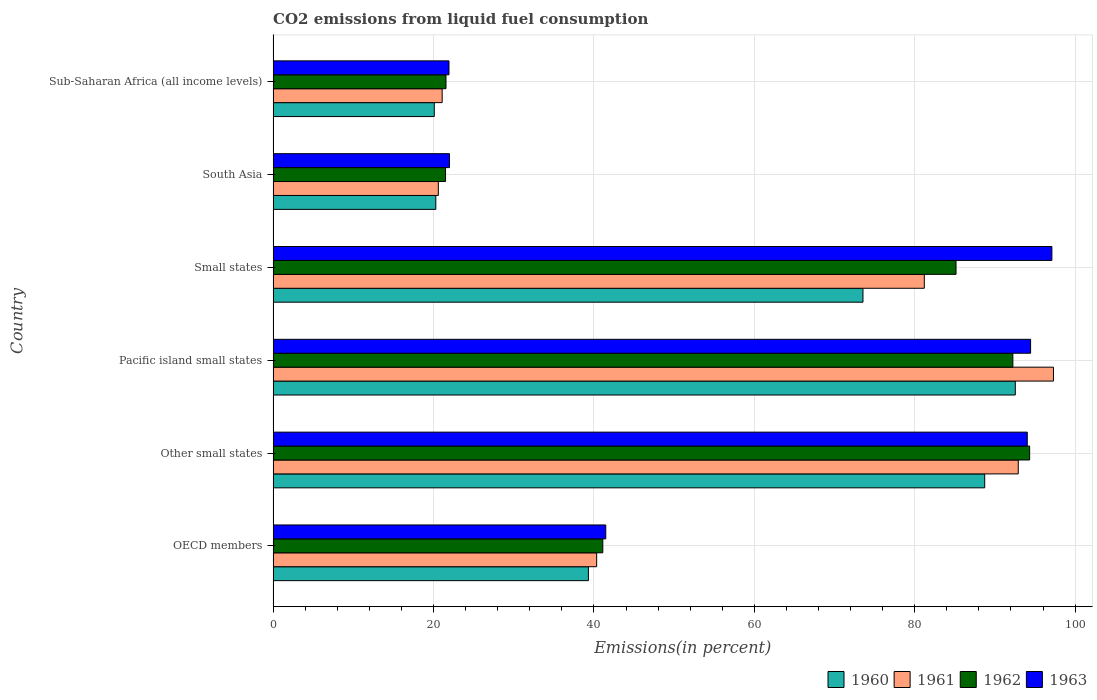How many different coloured bars are there?
Make the answer very short. 4. How many groups of bars are there?
Provide a short and direct response. 6. How many bars are there on the 2nd tick from the top?
Your answer should be very brief. 4. How many bars are there on the 1st tick from the bottom?
Your response must be concise. 4. What is the label of the 1st group of bars from the top?
Keep it short and to the point. Sub-Saharan Africa (all income levels). What is the total CO2 emitted in 1962 in Pacific island small states?
Offer a terse response. 92.23. Across all countries, what is the maximum total CO2 emitted in 1963?
Provide a succinct answer. 97.1. Across all countries, what is the minimum total CO2 emitted in 1963?
Ensure brevity in your answer.  21.93. In which country was the total CO2 emitted in 1962 maximum?
Give a very brief answer. Other small states. In which country was the total CO2 emitted in 1963 minimum?
Your response must be concise. Sub-Saharan Africa (all income levels). What is the total total CO2 emitted in 1962 in the graph?
Give a very brief answer. 355.86. What is the difference between the total CO2 emitted in 1963 in OECD members and that in South Asia?
Your answer should be compact. 19.49. What is the difference between the total CO2 emitted in 1962 in Pacific island small states and the total CO2 emitted in 1963 in Other small states?
Make the answer very short. -1.8. What is the average total CO2 emitted in 1961 per country?
Ensure brevity in your answer.  58.9. What is the difference between the total CO2 emitted in 1963 and total CO2 emitted in 1960 in Sub-Saharan Africa (all income levels)?
Make the answer very short. 1.83. What is the ratio of the total CO2 emitted in 1961 in Other small states to that in South Asia?
Make the answer very short. 4.51. What is the difference between the highest and the second highest total CO2 emitted in 1961?
Provide a short and direct response. 4.39. What is the difference between the highest and the lowest total CO2 emitted in 1961?
Make the answer very short. 76.7. Is the sum of the total CO2 emitted in 1963 in Other small states and South Asia greater than the maximum total CO2 emitted in 1960 across all countries?
Ensure brevity in your answer.  Yes. What does the 4th bar from the bottom in South Asia represents?
Offer a terse response. 1963. Is it the case that in every country, the sum of the total CO2 emitted in 1961 and total CO2 emitted in 1963 is greater than the total CO2 emitted in 1960?
Your response must be concise. Yes. How many bars are there?
Make the answer very short. 24. Are all the bars in the graph horizontal?
Make the answer very short. Yes. What is the difference between two consecutive major ticks on the X-axis?
Offer a very short reply. 20. Are the values on the major ticks of X-axis written in scientific E-notation?
Your answer should be very brief. No. Does the graph contain any zero values?
Make the answer very short. No. What is the title of the graph?
Your response must be concise. CO2 emissions from liquid fuel consumption. Does "1989" appear as one of the legend labels in the graph?
Make the answer very short. No. What is the label or title of the X-axis?
Your answer should be very brief. Emissions(in percent). What is the Emissions(in percent) in 1960 in OECD members?
Make the answer very short. 39.31. What is the Emissions(in percent) of 1961 in OECD members?
Ensure brevity in your answer.  40.34. What is the Emissions(in percent) of 1962 in OECD members?
Provide a short and direct response. 41.1. What is the Emissions(in percent) in 1963 in OECD members?
Your answer should be compact. 41.48. What is the Emissions(in percent) in 1960 in Other small states?
Offer a very short reply. 88.72. What is the Emissions(in percent) in 1961 in Other small states?
Your answer should be compact. 92.91. What is the Emissions(in percent) in 1962 in Other small states?
Ensure brevity in your answer.  94.33. What is the Emissions(in percent) in 1963 in Other small states?
Offer a very short reply. 94.03. What is the Emissions(in percent) of 1960 in Pacific island small states?
Your answer should be compact. 92.54. What is the Emissions(in percent) of 1961 in Pacific island small states?
Ensure brevity in your answer.  97.3. What is the Emissions(in percent) in 1962 in Pacific island small states?
Give a very brief answer. 92.23. What is the Emissions(in percent) of 1963 in Pacific island small states?
Your answer should be compact. 94.44. What is the Emissions(in percent) of 1960 in Small states?
Keep it short and to the point. 73.54. What is the Emissions(in percent) of 1961 in Small states?
Provide a short and direct response. 81.19. What is the Emissions(in percent) of 1962 in Small states?
Your answer should be compact. 85.15. What is the Emissions(in percent) in 1963 in Small states?
Your answer should be very brief. 97.1. What is the Emissions(in percent) in 1960 in South Asia?
Give a very brief answer. 20.29. What is the Emissions(in percent) in 1961 in South Asia?
Give a very brief answer. 20.6. What is the Emissions(in percent) in 1962 in South Asia?
Offer a very short reply. 21.5. What is the Emissions(in percent) in 1963 in South Asia?
Your answer should be very brief. 21.99. What is the Emissions(in percent) in 1960 in Sub-Saharan Africa (all income levels)?
Your answer should be very brief. 20.09. What is the Emissions(in percent) of 1961 in Sub-Saharan Africa (all income levels)?
Your answer should be compact. 21.08. What is the Emissions(in percent) of 1962 in Sub-Saharan Africa (all income levels)?
Offer a terse response. 21.55. What is the Emissions(in percent) in 1963 in Sub-Saharan Africa (all income levels)?
Make the answer very short. 21.93. Across all countries, what is the maximum Emissions(in percent) of 1960?
Your response must be concise. 92.54. Across all countries, what is the maximum Emissions(in percent) of 1961?
Give a very brief answer. 97.3. Across all countries, what is the maximum Emissions(in percent) of 1962?
Give a very brief answer. 94.33. Across all countries, what is the maximum Emissions(in percent) in 1963?
Give a very brief answer. 97.1. Across all countries, what is the minimum Emissions(in percent) of 1960?
Give a very brief answer. 20.09. Across all countries, what is the minimum Emissions(in percent) of 1961?
Your answer should be compact. 20.6. Across all countries, what is the minimum Emissions(in percent) of 1962?
Provide a succinct answer. 21.5. Across all countries, what is the minimum Emissions(in percent) of 1963?
Give a very brief answer. 21.93. What is the total Emissions(in percent) of 1960 in the graph?
Your response must be concise. 334.5. What is the total Emissions(in percent) of 1961 in the graph?
Keep it short and to the point. 353.41. What is the total Emissions(in percent) of 1962 in the graph?
Give a very brief answer. 355.86. What is the total Emissions(in percent) in 1963 in the graph?
Offer a very short reply. 370.97. What is the difference between the Emissions(in percent) of 1960 in OECD members and that in Other small states?
Provide a short and direct response. -49.41. What is the difference between the Emissions(in percent) of 1961 in OECD members and that in Other small states?
Make the answer very short. -52.57. What is the difference between the Emissions(in percent) of 1962 in OECD members and that in Other small states?
Give a very brief answer. -53.22. What is the difference between the Emissions(in percent) of 1963 in OECD members and that in Other small states?
Your response must be concise. -52.55. What is the difference between the Emissions(in percent) of 1960 in OECD members and that in Pacific island small states?
Your answer should be compact. -53.23. What is the difference between the Emissions(in percent) of 1961 in OECD members and that in Pacific island small states?
Your answer should be compact. -56.96. What is the difference between the Emissions(in percent) in 1962 in OECD members and that in Pacific island small states?
Make the answer very short. -51.13. What is the difference between the Emissions(in percent) in 1963 in OECD members and that in Pacific island small states?
Ensure brevity in your answer.  -52.97. What is the difference between the Emissions(in percent) in 1960 in OECD members and that in Small states?
Make the answer very short. -34.23. What is the difference between the Emissions(in percent) in 1961 in OECD members and that in Small states?
Offer a terse response. -40.85. What is the difference between the Emissions(in percent) in 1962 in OECD members and that in Small states?
Ensure brevity in your answer.  -44.04. What is the difference between the Emissions(in percent) of 1963 in OECD members and that in Small states?
Offer a very short reply. -55.62. What is the difference between the Emissions(in percent) of 1960 in OECD members and that in South Asia?
Offer a very short reply. 19.03. What is the difference between the Emissions(in percent) in 1961 in OECD members and that in South Asia?
Provide a short and direct response. 19.74. What is the difference between the Emissions(in percent) of 1962 in OECD members and that in South Asia?
Keep it short and to the point. 19.61. What is the difference between the Emissions(in percent) in 1963 in OECD members and that in South Asia?
Your answer should be very brief. 19.49. What is the difference between the Emissions(in percent) in 1960 in OECD members and that in Sub-Saharan Africa (all income levels)?
Make the answer very short. 19.22. What is the difference between the Emissions(in percent) in 1961 in OECD members and that in Sub-Saharan Africa (all income levels)?
Keep it short and to the point. 19.26. What is the difference between the Emissions(in percent) of 1962 in OECD members and that in Sub-Saharan Africa (all income levels)?
Your answer should be very brief. 19.55. What is the difference between the Emissions(in percent) in 1963 in OECD members and that in Sub-Saharan Africa (all income levels)?
Provide a short and direct response. 19.55. What is the difference between the Emissions(in percent) of 1960 in Other small states and that in Pacific island small states?
Ensure brevity in your answer.  -3.82. What is the difference between the Emissions(in percent) in 1961 in Other small states and that in Pacific island small states?
Your response must be concise. -4.39. What is the difference between the Emissions(in percent) in 1962 in Other small states and that in Pacific island small states?
Make the answer very short. 2.09. What is the difference between the Emissions(in percent) in 1963 in Other small states and that in Pacific island small states?
Provide a succinct answer. -0.41. What is the difference between the Emissions(in percent) in 1960 in Other small states and that in Small states?
Provide a short and direct response. 15.18. What is the difference between the Emissions(in percent) in 1961 in Other small states and that in Small states?
Your answer should be very brief. 11.72. What is the difference between the Emissions(in percent) of 1962 in Other small states and that in Small states?
Offer a very short reply. 9.18. What is the difference between the Emissions(in percent) of 1963 in Other small states and that in Small states?
Make the answer very short. -3.07. What is the difference between the Emissions(in percent) in 1960 in Other small states and that in South Asia?
Your answer should be very brief. 68.44. What is the difference between the Emissions(in percent) of 1961 in Other small states and that in South Asia?
Give a very brief answer. 72.31. What is the difference between the Emissions(in percent) of 1962 in Other small states and that in South Asia?
Your answer should be compact. 72.83. What is the difference between the Emissions(in percent) of 1963 in Other small states and that in South Asia?
Keep it short and to the point. 72.04. What is the difference between the Emissions(in percent) in 1960 in Other small states and that in Sub-Saharan Africa (all income levels)?
Your answer should be compact. 68.63. What is the difference between the Emissions(in percent) of 1961 in Other small states and that in Sub-Saharan Africa (all income levels)?
Keep it short and to the point. 71.83. What is the difference between the Emissions(in percent) of 1962 in Other small states and that in Sub-Saharan Africa (all income levels)?
Provide a short and direct response. 72.77. What is the difference between the Emissions(in percent) of 1963 in Other small states and that in Sub-Saharan Africa (all income levels)?
Your answer should be very brief. 72.1. What is the difference between the Emissions(in percent) of 1960 in Pacific island small states and that in Small states?
Keep it short and to the point. 18.99. What is the difference between the Emissions(in percent) in 1961 in Pacific island small states and that in Small states?
Keep it short and to the point. 16.1. What is the difference between the Emissions(in percent) in 1962 in Pacific island small states and that in Small states?
Offer a terse response. 7.09. What is the difference between the Emissions(in percent) of 1963 in Pacific island small states and that in Small states?
Offer a terse response. -2.66. What is the difference between the Emissions(in percent) in 1960 in Pacific island small states and that in South Asia?
Keep it short and to the point. 72.25. What is the difference between the Emissions(in percent) in 1961 in Pacific island small states and that in South Asia?
Your response must be concise. 76.7. What is the difference between the Emissions(in percent) of 1962 in Pacific island small states and that in South Asia?
Ensure brevity in your answer.  70.74. What is the difference between the Emissions(in percent) of 1963 in Pacific island small states and that in South Asia?
Offer a very short reply. 72.46. What is the difference between the Emissions(in percent) in 1960 in Pacific island small states and that in Sub-Saharan Africa (all income levels)?
Your answer should be very brief. 72.44. What is the difference between the Emissions(in percent) in 1961 in Pacific island small states and that in Sub-Saharan Africa (all income levels)?
Ensure brevity in your answer.  76.22. What is the difference between the Emissions(in percent) of 1962 in Pacific island small states and that in Sub-Saharan Africa (all income levels)?
Keep it short and to the point. 70.68. What is the difference between the Emissions(in percent) of 1963 in Pacific island small states and that in Sub-Saharan Africa (all income levels)?
Provide a succinct answer. 72.52. What is the difference between the Emissions(in percent) in 1960 in Small states and that in South Asia?
Provide a short and direct response. 53.26. What is the difference between the Emissions(in percent) of 1961 in Small states and that in South Asia?
Offer a very short reply. 60.59. What is the difference between the Emissions(in percent) in 1962 in Small states and that in South Asia?
Make the answer very short. 63.65. What is the difference between the Emissions(in percent) in 1963 in Small states and that in South Asia?
Make the answer very short. 75.11. What is the difference between the Emissions(in percent) of 1960 in Small states and that in Sub-Saharan Africa (all income levels)?
Offer a terse response. 53.45. What is the difference between the Emissions(in percent) of 1961 in Small states and that in Sub-Saharan Africa (all income levels)?
Ensure brevity in your answer.  60.12. What is the difference between the Emissions(in percent) in 1962 in Small states and that in Sub-Saharan Africa (all income levels)?
Ensure brevity in your answer.  63.59. What is the difference between the Emissions(in percent) of 1963 in Small states and that in Sub-Saharan Africa (all income levels)?
Your answer should be very brief. 75.17. What is the difference between the Emissions(in percent) of 1960 in South Asia and that in Sub-Saharan Africa (all income levels)?
Offer a terse response. 0.19. What is the difference between the Emissions(in percent) of 1961 in South Asia and that in Sub-Saharan Africa (all income levels)?
Your answer should be compact. -0.48. What is the difference between the Emissions(in percent) in 1962 in South Asia and that in Sub-Saharan Africa (all income levels)?
Give a very brief answer. -0.06. What is the difference between the Emissions(in percent) of 1963 in South Asia and that in Sub-Saharan Africa (all income levels)?
Ensure brevity in your answer.  0.06. What is the difference between the Emissions(in percent) in 1960 in OECD members and the Emissions(in percent) in 1961 in Other small states?
Give a very brief answer. -53.6. What is the difference between the Emissions(in percent) in 1960 in OECD members and the Emissions(in percent) in 1962 in Other small states?
Keep it short and to the point. -55.01. What is the difference between the Emissions(in percent) in 1960 in OECD members and the Emissions(in percent) in 1963 in Other small states?
Make the answer very short. -54.72. What is the difference between the Emissions(in percent) in 1961 in OECD members and the Emissions(in percent) in 1962 in Other small states?
Provide a short and direct response. -53.99. What is the difference between the Emissions(in percent) in 1961 in OECD members and the Emissions(in percent) in 1963 in Other small states?
Keep it short and to the point. -53.69. What is the difference between the Emissions(in percent) in 1962 in OECD members and the Emissions(in percent) in 1963 in Other small states?
Offer a terse response. -52.93. What is the difference between the Emissions(in percent) in 1960 in OECD members and the Emissions(in percent) in 1961 in Pacific island small states?
Make the answer very short. -57.99. What is the difference between the Emissions(in percent) of 1960 in OECD members and the Emissions(in percent) of 1962 in Pacific island small states?
Your answer should be very brief. -52.92. What is the difference between the Emissions(in percent) in 1960 in OECD members and the Emissions(in percent) in 1963 in Pacific island small states?
Offer a very short reply. -55.13. What is the difference between the Emissions(in percent) of 1961 in OECD members and the Emissions(in percent) of 1962 in Pacific island small states?
Ensure brevity in your answer.  -51.89. What is the difference between the Emissions(in percent) of 1961 in OECD members and the Emissions(in percent) of 1963 in Pacific island small states?
Your answer should be very brief. -54.1. What is the difference between the Emissions(in percent) of 1962 in OECD members and the Emissions(in percent) of 1963 in Pacific island small states?
Make the answer very short. -53.34. What is the difference between the Emissions(in percent) of 1960 in OECD members and the Emissions(in percent) of 1961 in Small states?
Your response must be concise. -41.88. What is the difference between the Emissions(in percent) of 1960 in OECD members and the Emissions(in percent) of 1962 in Small states?
Offer a terse response. -45.84. What is the difference between the Emissions(in percent) in 1960 in OECD members and the Emissions(in percent) in 1963 in Small states?
Provide a succinct answer. -57.79. What is the difference between the Emissions(in percent) of 1961 in OECD members and the Emissions(in percent) of 1962 in Small states?
Keep it short and to the point. -44.81. What is the difference between the Emissions(in percent) in 1961 in OECD members and the Emissions(in percent) in 1963 in Small states?
Your answer should be compact. -56.76. What is the difference between the Emissions(in percent) in 1962 in OECD members and the Emissions(in percent) in 1963 in Small states?
Provide a succinct answer. -55.99. What is the difference between the Emissions(in percent) of 1960 in OECD members and the Emissions(in percent) of 1961 in South Asia?
Make the answer very short. 18.71. What is the difference between the Emissions(in percent) in 1960 in OECD members and the Emissions(in percent) in 1962 in South Asia?
Offer a very short reply. 17.82. What is the difference between the Emissions(in percent) in 1960 in OECD members and the Emissions(in percent) in 1963 in South Asia?
Your answer should be compact. 17.32. What is the difference between the Emissions(in percent) in 1961 in OECD members and the Emissions(in percent) in 1962 in South Asia?
Your answer should be very brief. 18.84. What is the difference between the Emissions(in percent) in 1961 in OECD members and the Emissions(in percent) in 1963 in South Asia?
Keep it short and to the point. 18.35. What is the difference between the Emissions(in percent) in 1962 in OECD members and the Emissions(in percent) in 1963 in South Asia?
Your answer should be very brief. 19.12. What is the difference between the Emissions(in percent) in 1960 in OECD members and the Emissions(in percent) in 1961 in Sub-Saharan Africa (all income levels)?
Your answer should be very brief. 18.23. What is the difference between the Emissions(in percent) of 1960 in OECD members and the Emissions(in percent) of 1962 in Sub-Saharan Africa (all income levels)?
Offer a terse response. 17.76. What is the difference between the Emissions(in percent) in 1960 in OECD members and the Emissions(in percent) in 1963 in Sub-Saharan Africa (all income levels)?
Provide a succinct answer. 17.38. What is the difference between the Emissions(in percent) in 1961 in OECD members and the Emissions(in percent) in 1962 in Sub-Saharan Africa (all income levels)?
Keep it short and to the point. 18.79. What is the difference between the Emissions(in percent) in 1961 in OECD members and the Emissions(in percent) in 1963 in Sub-Saharan Africa (all income levels)?
Offer a very short reply. 18.41. What is the difference between the Emissions(in percent) of 1962 in OECD members and the Emissions(in percent) of 1963 in Sub-Saharan Africa (all income levels)?
Offer a terse response. 19.18. What is the difference between the Emissions(in percent) of 1960 in Other small states and the Emissions(in percent) of 1961 in Pacific island small states?
Keep it short and to the point. -8.58. What is the difference between the Emissions(in percent) of 1960 in Other small states and the Emissions(in percent) of 1962 in Pacific island small states?
Make the answer very short. -3.51. What is the difference between the Emissions(in percent) in 1960 in Other small states and the Emissions(in percent) in 1963 in Pacific island small states?
Your response must be concise. -5.72. What is the difference between the Emissions(in percent) in 1961 in Other small states and the Emissions(in percent) in 1962 in Pacific island small states?
Offer a very short reply. 0.67. What is the difference between the Emissions(in percent) in 1961 in Other small states and the Emissions(in percent) in 1963 in Pacific island small states?
Ensure brevity in your answer.  -1.54. What is the difference between the Emissions(in percent) in 1962 in Other small states and the Emissions(in percent) in 1963 in Pacific island small states?
Provide a short and direct response. -0.12. What is the difference between the Emissions(in percent) in 1960 in Other small states and the Emissions(in percent) in 1961 in Small states?
Ensure brevity in your answer.  7.53. What is the difference between the Emissions(in percent) in 1960 in Other small states and the Emissions(in percent) in 1962 in Small states?
Make the answer very short. 3.57. What is the difference between the Emissions(in percent) in 1960 in Other small states and the Emissions(in percent) in 1963 in Small states?
Give a very brief answer. -8.38. What is the difference between the Emissions(in percent) in 1961 in Other small states and the Emissions(in percent) in 1962 in Small states?
Your answer should be very brief. 7.76. What is the difference between the Emissions(in percent) in 1961 in Other small states and the Emissions(in percent) in 1963 in Small states?
Give a very brief answer. -4.19. What is the difference between the Emissions(in percent) of 1962 in Other small states and the Emissions(in percent) of 1963 in Small states?
Ensure brevity in your answer.  -2.77. What is the difference between the Emissions(in percent) in 1960 in Other small states and the Emissions(in percent) in 1961 in South Asia?
Offer a very short reply. 68.12. What is the difference between the Emissions(in percent) of 1960 in Other small states and the Emissions(in percent) of 1962 in South Asia?
Your answer should be compact. 67.23. What is the difference between the Emissions(in percent) of 1960 in Other small states and the Emissions(in percent) of 1963 in South Asia?
Offer a very short reply. 66.73. What is the difference between the Emissions(in percent) in 1961 in Other small states and the Emissions(in percent) in 1962 in South Asia?
Give a very brief answer. 71.41. What is the difference between the Emissions(in percent) in 1961 in Other small states and the Emissions(in percent) in 1963 in South Asia?
Provide a succinct answer. 70.92. What is the difference between the Emissions(in percent) in 1962 in Other small states and the Emissions(in percent) in 1963 in South Asia?
Make the answer very short. 72.34. What is the difference between the Emissions(in percent) of 1960 in Other small states and the Emissions(in percent) of 1961 in Sub-Saharan Africa (all income levels)?
Ensure brevity in your answer.  67.64. What is the difference between the Emissions(in percent) in 1960 in Other small states and the Emissions(in percent) in 1962 in Sub-Saharan Africa (all income levels)?
Offer a very short reply. 67.17. What is the difference between the Emissions(in percent) of 1960 in Other small states and the Emissions(in percent) of 1963 in Sub-Saharan Africa (all income levels)?
Ensure brevity in your answer.  66.79. What is the difference between the Emissions(in percent) of 1961 in Other small states and the Emissions(in percent) of 1962 in Sub-Saharan Africa (all income levels)?
Your answer should be compact. 71.35. What is the difference between the Emissions(in percent) in 1961 in Other small states and the Emissions(in percent) in 1963 in Sub-Saharan Africa (all income levels)?
Give a very brief answer. 70.98. What is the difference between the Emissions(in percent) in 1962 in Other small states and the Emissions(in percent) in 1963 in Sub-Saharan Africa (all income levels)?
Give a very brief answer. 72.4. What is the difference between the Emissions(in percent) in 1960 in Pacific island small states and the Emissions(in percent) in 1961 in Small states?
Provide a short and direct response. 11.34. What is the difference between the Emissions(in percent) in 1960 in Pacific island small states and the Emissions(in percent) in 1962 in Small states?
Provide a short and direct response. 7.39. What is the difference between the Emissions(in percent) in 1960 in Pacific island small states and the Emissions(in percent) in 1963 in Small states?
Give a very brief answer. -4.56. What is the difference between the Emissions(in percent) of 1961 in Pacific island small states and the Emissions(in percent) of 1962 in Small states?
Provide a succinct answer. 12.15. What is the difference between the Emissions(in percent) of 1961 in Pacific island small states and the Emissions(in percent) of 1963 in Small states?
Give a very brief answer. 0.2. What is the difference between the Emissions(in percent) of 1962 in Pacific island small states and the Emissions(in percent) of 1963 in Small states?
Offer a terse response. -4.87. What is the difference between the Emissions(in percent) of 1960 in Pacific island small states and the Emissions(in percent) of 1961 in South Asia?
Ensure brevity in your answer.  71.94. What is the difference between the Emissions(in percent) in 1960 in Pacific island small states and the Emissions(in percent) in 1962 in South Asia?
Provide a succinct answer. 71.04. What is the difference between the Emissions(in percent) in 1960 in Pacific island small states and the Emissions(in percent) in 1963 in South Asia?
Make the answer very short. 70.55. What is the difference between the Emissions(in percent) of 1961 in Pacific island small states and the Emissions(in percent) of 1962 in South Asia?
Make the answer very short. 75.8. What is the difference between the Emissions(in percent) of 1961 in Pacific island small states and the Emissions(in percent) of 1963 in South Asia?
Make the answer very short. 75.31. What is the difference between the Emissions(in percent) of 1962 in Pacific island small states and the Emissions(in percent) of 1963 in South Asia?
Give a very brief answer. 70.24. What is the difference between the Emissions(in percent) of 1960 in Pacific island small states and the Emissions(in percent) of 1961 in Sub-Saharan Africa (all income levels)?
Ensure brevity in your answer.  71.46. What is the difference between the Emissions(in percent) of 1960 in Pacific island small states and the Emissions(in percent) of 1962 in Sub-Saharan Africa (all income levels)?
Offer a terse response. 70.98. What is the difference between the Emissions(in percent) in 1960 in Pacific island small states and the Emissions(in percent) in 1963 in Sub-Saharan Africa (all income levels)?
Provide a short and direct response. 70.61. What is the difference between the Emissions(in percent) in 1961 in Pacific island small states and the Emissions(in percent) in 1962 in Sub-Saharan Africa (all income levels)?
Offer a very short reply. 75.74. What is the difference between the Emissions(in percent) in 1961 in Pacific island small states and the Emissions(in percent) in 1963 in Sub-Saharan Africa (all income levels)?
Your answer should be compact. 75.37. What is the difference between the Emissions(in percent) of 1962 in Pacific island small states and the Emissions(in percent) of 1963 in Sub-Saharan Africa (all income levels)?
Provide a succinct answer. 70.31. What is the difference between the Emissions(in percent) of 1960 in Small states and the Emissions(in percent) of 1961 in South Asia?
Make the answer very short. 52.94. What is the difference between the Emissions(in percent) of 1960 in Small states and the Emissions(in percent) of 1962 in South Asia?
Your response must be concise. 52.05. What is the difference between the Emissions(in percent) of 1960 in Small states and the Emissions(in percent) of 1963 in South Asia?
Keep it short and to the point. 51.56. What is the difference between the Emissions(in percent) in 1961 in Small states and the Emissions(in percent) in 1962 in South Asia?
Offer a very short reply. 59.7. What is the difference between the Emissions(in percent) in 1961 in Small states and the Emissions(in percent) in 1963 in South Asia?
Ensure brevity in your answer.  59.2. What is the difference between the Emissions(in percent) of 1962 in Small states and the Emissions(in percent) of 1963 in South Asia?
Your response must be concise. 63.16. What is the difference between the Emissions(in percent) in 1960 in Small states and the Emissions(in percent) in 1961 in Sub-Saharan Africa (all income levels)?
Offer a terse response. 52.47. What is the difference between the Emissions(in percent) of 1960 in Small states and the Emissions(in percent) of 1962 in Sub-Saharan Africa (all income levels)?
Keep it short and to the point. 51.99. What is the difference between the Emissions(in percent) of 1960 in Small states and the Emissions(in percent) of 1963 in Sub-Saharan Africa (all income levels)?
Offer a terse response. 51.62. What is the difference between the Emissions(in percent) of 1961 in Small states and the Emissions(in percent) of 1962 in Sub-Saharan Africa (all income levels)?
Ensure brevity in your answer.  59.64. What is the difference between the Emissions(in percent) in 1961 in Small states and the Emissions(in percent) in 1963 in Sub-Saharan Africa (all income levels)?
Your response must be concise. 59.26. What is the difference between the Emissions(in percent) in 1962 in Small states and the Emissions(in percent) in 1963 in Sub-Saharan Africa (all income levels)?
Your answer should be very brief. 63.22. What is the difference between the Emissions(in percent) in 1960 in South Asia and the Emissions(in percent) in 1961 in Sub-Saharan Africa (all income levels)?
Give a very brief answer. -0.79. What is the difference between the Emissions(in percent) in 1960 in South Asia and the Emissions(in percent) in 1962 in Sub-Saharan Africa (all income levels)?
Your answer should be compact. -1.27. What is the difference between the Emissions(in percent) of 1960 in South Asia and the Emissions(in percent) of 1963 in Sub-Saharan Africa (all income levels)?
Your answer should be compact. -1.64. What is the difference between the Emissions(in percent) in 1961 in South Asia and the Emissions(in percent) in 1962 in Sub-Saharan Africa (all income levels)?
Ensure brevity in your answer.  -0.95. What is the difference between the Emissions(in percent) in 1961 in South Asia and the Emissions(in percent) in 1963 in Sub-Saharan Africa (all income levels)?
Your answer should be compact. -1.33. What is the difference between the Emissions(in percent) in 1962 in South Asia and the Emissions(in percent) in 1963 in Sub-Saharan Africa (all income levels)?
Ensure brevity in your answer.  -0.43. What is the average Emissions(in percent) of 1960 per country?
Offer a terse response. 55.75. What is the average Emissions(in percent) in 1961 per country?
Give a very brief answer. 58.9. What is the average Emissions(in percent) of 1962 per country?
Ensure brevity in your answer.  59.31. What is the average Emissions(in percent) in 1963 per country?
Make the answer very short. 61.83. What is the difference between the Emissions(in percent) in 1960 and Emissions(in percent) in 1961 in OECD members?
Provide a short and direct response. -1.03. What is the difference between the Emissions(in percent) in 1960 and Emissions(in percent) in 1962 in OECD members?
Provide a succinct answer. -1.79. What is the difference between the Emissions(in percent) of 1960 and Emissions(in percent) of 1963 in OECD members?
Ensure brevity in your answer.  -2.16. What is the difference between the Emissions(in percent) in 1961 and Emissions(in percent) in 1962 in OECD members?
Provide a succinct answer. -0.76. What is the difference between the Emissions(in percent) in 1961 and Emissions(in percent) in 1963 in OECD members?
Provide a short and direct response. -1.14. What is the difference between the Emissions(in percent) in 1962 and Emissions(in percent) in 1963 in OECD members?
Keep it short and to the point. -0.37. What is the difference between the Emissions(in percent) in 1960 and Emissions(in percent) in 1961 in Other small states?
Your response must be concise. -4.19. What is the difference between the Emissions(in percent) in 1960 and Emissions(in percent) in 1962 in Other small states?
Make the answer very short. -5.6. What is the difference between the Emissions(in percent) in 1960 and Emissions(in percent) in 1963 in Other small states?
Offer a terse response. -5.31. What is the difference between the Emissions(in percent) of 1961 and Emissions(in percent) of 1962 in Other small states?
Provide a short and direct response. -1.42. What is the difference between the Emissions(in percent) of 1961 and Emissions(in percent) of 1963 in Other small states?
Keep it short and to the point. -1.12. What is the difference between the Emissions(in percent) of 1962 and Emissions(in percent) of 1963 in Other small states?
Offer a terse response. 0.3. What is the difference between the Emissions(in percent) in 1960 and Emissions(in percent) in 1961 in Pacific island small states?
Your answer should be very brief. -4.76. What is the difference between the Emissions(in percent) of 1960 and Emissions(in percent) of 1962 in Pacific island small states?
Provide a succinct answer. 0.3. What is the difference between the Emissions(in percent) of 1960 and Emissions(in percent) of 1963 in Pacific island small states?
Ensure brevity in your answer.  -1.91. What is the difference between the Emissions(in percent) in 1961 and Emissions(in percent) in 1962 in Pacific island small states?
Provide a short and direct response. 5.06. What is the difference between the Emissions(in percent) in 1961 and Emissions(in percent) in 1963 in Pacific island small states?
Give a very brief answer. 2.85. What is the difference between the Emissions(in percent) in 1962 and Emissions(in percent) in 1963 in Pacific island small states?
Give a very brief answer. -2.21. What is the difference between the Emissions(in percent) of 1960 and Emissions(in percent) of 1961 in Small states?
Your answer should be compact. -7.65. What is the difference between the Emissions(in percent) in 1960 and Emissions(in percent) in 1962 in Small states?
Give a very brief answer. -11.6. What is the difference between the Emissions(in percent) of 1960 and Emissions(in percent) of 1963 in Small states?
Offer a very short reply. -23.56. What is the difference between the Emissions(in percent) of 1961 and Emissions(in percent) of 1962 in Small states?
Your answer should be compact. -3.96. What is the difference between the Emissions(in percent) in 1961 and Emissions(in percent) in 1963 in Small states?
Provide a short and direct response. -15.91. What is the difference between the Emissions(in percent) in 1962 and Emissions(in percent) in 1963 in Small states?
Keep it short and to the point. -11.95. What is the difference between the Emissions(in percent) in 1960 and Emissions(in percent) in 1961 in South Asia?
Your response must be concise. -0.31. What is the difference between the Emissions(in percent) in 1960 and Emissions(in percent) in 1962 in South Asia?
Provide a succinct answer. -1.21. What is the difference between the Emissions(in percent) in 1960 and Emissions(in percent) in 1963 in South Asia?
Offer a very short reply. -1.7. What is the difference between the Emissions(in percent) in 1961 and Emissions(in percent) in 1962 in South Asia?
Offer a very short reply. -0.9. What is the difference between the Emissions(in percent) in 1961 and Emissions(in percent) in 1963 in South Asia?
Offer a terse response. -1.39. What is the difference between the Emissions(in percent) in 1962 and Emissions(in percent) in 1963 in South Asia?
Your response must be concise. -0.49. What is the difference between the Emissions(in percent) in 1960 and Emissions(in percent) in 1961 in Sub-Saharan Africa (all income levels)?
Make the answer very short. -0.98. What is the difference between the Emissions(in percent) of 1960 and Emissions(in percent) of 1962 in Sub-Saharan Africa (all income levels)?
Make the answer very short. -1.46. What is the difference between the Emissions(in percent) of 1960 and Emissions(in percent) of 1963 in Sub-Saharan Africa (all income levels)?
Your response must be concise. -1.83. What is the difference between the Emissions(in percent) of 1961 and Emissions(in percent) of 1962 in Sub-Saharan Africa (all income levels)?
Offer a very short reply. -0.48. What is the difference between the Emissions(in percent) in 1961 and Emissions(in percent) in 1963 in Sub-Saharan Africa (all income levels)?
Give a very brief answer. -0.85. What is the difference between the Emissions(in percent) in 1962 and Emissions(in percent) in 1963 in Sub-Saharan Africa (all income levels)?
Keep it short and to the point. -0.37. What is the ratio of the Emissions(in percent) of 1960 in OECD members to that in Other small states?
Keep it short and to the point. 0.44. What is the ratio of the Emissions(in percent) of 1961 in OECD members to that in Other small states?
Provide a succinct answer. 0.43. What is the ratio of the Emissions(in percent) of 1962 in OECD members to that in Other small states?
Your answer should be very brief. 0.44. What is the ratio of the Emissions(in percent) in 1963 in OECD members to that in Other small states?
Your response must be concise. 0.44. What is the ratio of the Emissions(in percent) in 1960 in OECD members to that in Pacific island small states?
Offer a terse response. 0.42. What is the ratio of the Emissions(in percent) in 1961 in OECD members to that in Pacific island small states?
Ensure brevity in your answer.  0.41. What is the ratio of the Emissions(in percent) in 1962 in OECD members to that in Pacific island small states?
Your answer should be compact. 0.45. What is the ratio of the Emissions(in percent) in 1963 in OECD members to that in Pacific island small states?
Your answer should be compact. 0.44. What is the ratio of the Emissions(in percent) in 1960 in OECD members to that in Small states?
Your answer should be very brief. 0.53. What is the ratio of the Emissions(in percent) in 1961 in OECD members to that in Small states?
Offer a terse response. 0.5. What is the ratio of the Emissions(in percent) of 1962 in OECD members to that in Small states?
Give a very brief answer. 0.48. What is the ratio of the Emissions(in percent) of 1963 in OECD members to that in Small states?
Provide a short and direct response. 0.43. What is the ratio of the Emissions(in percent) of 1960 in OECD members to that in South Asia?
Keep it short and to the point. 1.94. What is the ratio of the Emissions(in percent) in 1961 in OECD members to that in South Asia?
Your answer should be very brief. 1.96. What is the ratio of the Emissions(in percent) of 1962 in OECD members to that in South Asia?
Give a very brief answer. 1.91. What is the ratio of the Emissions(in percent) in 1963 in OECD members to that in South Asia?
Your answer should be very brief. 1.89. What is the ratio of the Emissions(in percent) of 1960 in OECD members to that in Sub-Saharan Africa (all income levels)?
Your answer should be compact. 1.96. What is the ratio of the Emissions(in percent) of 1961 in OECD members to that in Sub-Saharan Africa (all income levels)?
Provide a succinct answer. 1.91. What is the ratio of the Emissions(in percent) in 1962 in OECD members to that in Sub-Saharan Africa (all income levels)?
Keep it short and to the point. 1.91. What is the ratio of the Emissions(in percent) of 1963 in OECD members to that in Sub-Saharan Africa (all income levels)?
Your answer should be compact. 1.89. What is the ratio of the Emissions(in percent) of 1960 in Other small states to that in Pacific island small states?
Your response must be concise. 0.96. What is the ratio of the Emissions(in percent) in 1961 in Other small states to that in Pacific island small states?
Provide a short and direct response. 0.95. What is the ratio of the Emissions(in percent) in 1962 in Other small states to that in Pacific island small states?
Give a very brief answer. 1.02. What is the ratio of the Emissions(in percent) in 1963 in Other small states to that in Pacific island small states?
Make the answer very short. 1. What is the ratio of the Emissions(in percent) in 1960 in Other small states to that in Small states?
Offer a very short reply. 1.21. What is the ratio of the Emissions(in percent) in 1961 in Other small states to that in Small states?
Provide a short and direct response. 1.14. What is the ratio of the Emissions(in percent) in 1962 in Other small states to that in Small states?
Ensure brevity in your answer.  1.11. What is the ratio of the Emissions(in percent) in 1963 in Other small states to that in Small states?
Ensure brevity in your answer.  0.97. What is the ratio of the Emissions(in percent) of 1960 in Other small states to that in South Asia?
Make the answer very short. 4.37. What is the ratio of the Emissions(in percent) of 1961 in Other small states to that in South Asia?
Your answer should be very brief. 4.51. What is the ratio of the Emissions(in percent) of 1962 in Other small states to that in South Asia?
Ensure brevity in your answer.  4.39. What is the ratio of the Emissions(in percent) of 1963 in Other small states to that in South Asia?
Provide a short and direct response. 4.28. What is the ratio of the Emissions(in percent) of 1960 in Other small states to that in Sub-Saharan Africa (all income levels)?
Make the answer very short. 4.42. What is the ratio of the Emissions(in percent) in 1961 in Other small states to that in Sub-Saharan Africa (all income levels)?
Ensure brevity in your answer.  4.41. What is the ratio of the Emissions(in percent) in 1962 in Other small states to that in Sub-Saharan Africa (all income levels)?
Offer a terse response. 4.38. What is the ratio of the Emissions(in percent) in 1963 in Other small states to that in Sub-Saharan Africa (all income levels)?
Ensure brevity in your answer.  4.29. What is the ratio of the Emissions(in percent) of 1960 in Pacific island small states to that in Small states?
Provide a succinct answer. 1.26. What is the ratio of the Emissions(in percent) in 1961 in Pacific island small states to that in Small states?
Your response must be concise. 1.2. What is the ratio of the Emissions(in percent) in 1962 in Pacific island small states to that in Small states?
Provide a short and direct response. 1.08. What is the ratio of the Emissions(in percent) in 1963 in Pacific island small states to that in Small states?
Your answer should be very brief. 0.97. What is the ratio of the Emissions(in percent) in 1960 in Pacific island small states to that in South Asia?
Your answer should be very brief. 4.56. What is the ratio of the Emissions(in percent) in 1961 in Pacific island small states to that in South Asia?
Your response must be concise. 4.72. What is the ratio of the Emissions(in percent) of 1962 in Pacific island small states to that in South Asia?
Your answer should be very brief. 4.29. What is the ratio of the Emissions(in percent) in 1963 in Pacific island small states to that in South Asia?
Provide a short and direct response. 4.3. What is the ratio of the Emissions(in percent) of 1960 in Pacific island small states to that in Sub-Saharan Africa (all income levels)?
Provide a short and direct response. 4.61. What is the ratio of the Emissions(in percent) in 1961 in Pacific island small states to that in Sub-Saharan Africa (all income levels)?
Your answer should be compact. 4.62. What is the ratio of the Emissions(in percent) in 1962 in Pacific island small states to that in Sub-Saharan Africa (all income levels)?
Ensure brevity in your answer.  4.28. What is the ratio of the Emissions(in percent) of 1963 in Pacific island small states to that in Sub-Saharan Africa (all income levels)?
Make the answer very short. 4.31. What is the ratio of the Emissions(in percent) in 1960 in Small states to that in South Asia?
Give a very brief answer. 3.63. What is the ratio of the Emissions(in percent) of 1961 in Small states to that in South Asia?
Keep it short and to the point. 3.94. What is the ratio of the Emissions(in percent) in 1962 in Small states to that in South Asia?
Offer a terse response. 3.96. What is the ratio of the Emissions(in percent) in 1963 in Small states to that in South Asia?
Offer a terse response. 4.42. What is the ratio of the Emissions(in percent) in 1960 in Small states to that in Sub-Saharan Africa (all income levels)?
Keep it short and to the point. 3.66. What is the ratio of the Emissions(in percent) of 1961 in Small states to that in Sub-Saharan Africa (all income levels)?
Offer a very short reply. 3.85. What is the ratio of the Emissions(in percent) in 1962 in Small states to that in Sub-Saharan Africa (all income levels)?
Give a very brief answer. 3.95. What is the ratio of the Emissions(in percent) in 1963 in Small states to that in Sub-Saharan Africa (all income levels)?
Provide a short and direct response. 4.43. What is the ratio of the Emissions(in percent) of 1960 in South Asia to that in Sub-Saharan Africa (all income levels)?
Keep it short and to the point. 1.01. What is the ratio of the Emissions(in percent) of 1961 in South Asia to that in Sub-Saharan Africa (all income levels)?
Give a very brief answer. 0.98. What is the ratio of the Emissions(in percent) in 1962 in South Asia to that in Sub-Saharan Africa (all income levels)?
Your answer should be very brief. 1. What is the ratio of the Emissions(in percent) in 1963 in South Asia to that in Sub-Saharan Africa (all income levels)?
Provide a succinct answer. 1. What is the difference between the highest and the second highest Emissions(in percent) of 1960?
Your response must be concise. 3.82. What is the difference between the highest and the second highest Emissions(in percent) in 1961?
Keep it short and to the point. 4.39. What is the difference between the highest and the second highest Emissions(in percent) in 1962?
Provide a succinct answer. 2.09. What is the difference between the highest and the second highest Emissions(in percent) of 1963?
Provide a succinct answer. 2.66. What is the difference between the highest and the lowest Emissions(in percent) of 1960?
Ensure brevity in your answer.  72.44. What is the difference between the highest and the lowest Emissions(in percent) of 1961?
Your answer should be compact. 76.7. What is the difference between the highest and the lowest Emissions(in percent) of 1962?
Provide a succinct answer. 72.83. What is the difference between the highest and the lowest Emissions(in percent) of 1963?
Ensure brevity in your answer.  75.17. 